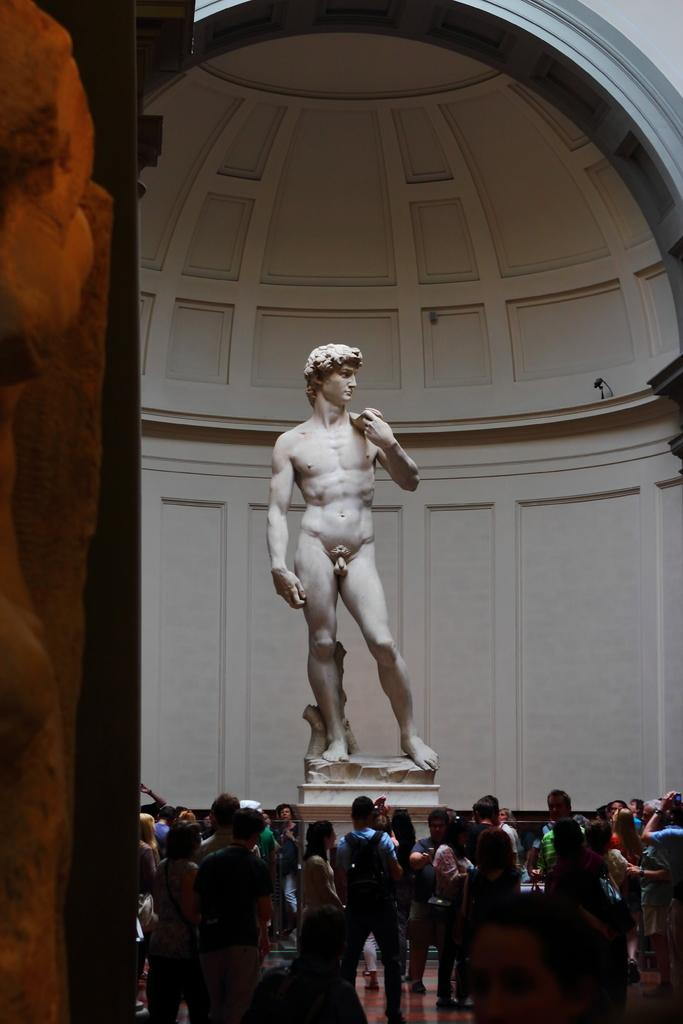What is happening in the image? There are persons standing in a group in the image. What can be seen besides the group of people? There is a statue of a man in the image. What is visible in the background of the image? There is a wall in the background of the image. What type of news can be heard coming from the statue in the image? There is no indication in the image that the statue is producing any news, as statues are not capable of speaking or making sounds. 